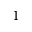Convert formula to latex. <formula><loc_0><loc_0><loc_500><loc_500>^ { 1 }</formula> 